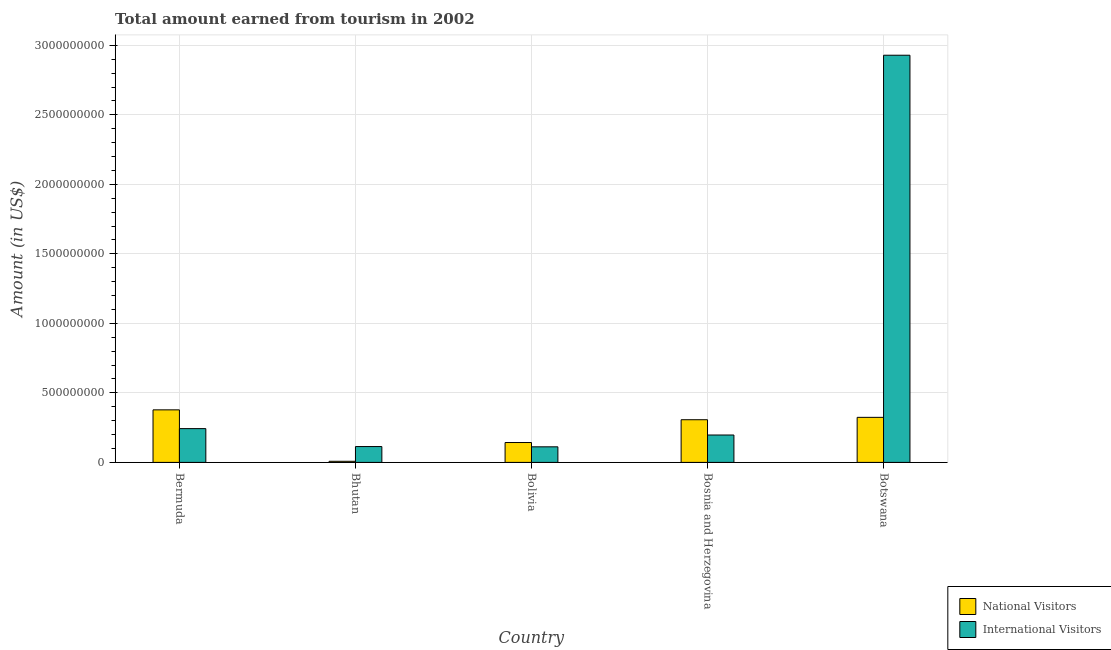How many different coloured bars are there?
Your answer should be very brief. 2. How many groups of bars are there?
Ensure brevity in your answer.  5. Are the number of bars on each tick of the X-axis equal?
Make the answer very short. Yes. How many bars are there on the 1st tick from the left?
Ensure brevity in your answer.  2. What is the label of the 2nd group of bars from the left?
Make the answer very short. Bhutan. In how many cases, is the number of bars for a given country not equal to the number of legend labels?
Make the answer very short. 0. Across all countries, what is the maximum amount earned from national visitors?
Make the answer very short. 3.78e+08. In which country was the amount earned from international visitors maximum?
Your answer should be compact. Botswana. In which country was the amount earned from international visitors minimum?
Make the answer very short. Bolivia. What is the total amount earned from international visitors in the graph?
Your response must be concise. 3.60e+09. What is the difference between the amount earned from international visitors in Bosnia and Herzegovina and that in Botswana?
Your response must be concise. -2.73e+09. What is the difference between the amount earned from national visitors in Bhutan and the amount earned from international visitors in Bosnia and Herzegovina?
Offer a very short reply. -1.89e+08. What is the average amount earned from international visitors per country?
Make the answer very short. 7.19e+08. What is the difference between the amount earned from international visitors and amount earned from national visitors in Bolivia?
Make the answer very short. -3.10e+07. In how many countries, is the amount earned from international visitors greater than 2600000000 US$?
Your answer should be very brief. 1. What is the ratio of the amount earned from international visitors in Bermuda to that in Bolivia?
Your answer should be compact. 2.17. Is the amount earned from national visitors in Bermuda less than that in Botswana?
Ensure brevity in your answer.  No. What is the difference between the highest and the second highest amount earned from national visitors?
Give a very brief answer. 5.40e+07. What is the difference between the highest and the lowest amount earned from international visitors?
Give a very brief answer. 2.82e+09. In how many countries, is the amount earned from national visitors greater than the average amount earned from national visitors taken over all countries?
Your response must be concise. 3. Is the sum of the amount earned from international visitors in Bolivia and Botswana greater than the maximum amount earned from national visitors across all countries?
Keep it short and to the point. Yes. What does the 2nd bar from the left in Bhutan represents?
Offer a terse response. International Visitors. What does the 2nd bar from the right in Bermuda represents?
Give a very brief answer. National Visitors. How many bars are there?
Offer a terse response. 10. How many countries are there in the graph?
Provide a short and direct response. 5. What is the difference between two consecutive major ticks on the Y-axis?
Keep it short and to the point. 5.00e+08. Where does the legend appear in the graph?
Make the answer very short. Bottom right. How many legend labels are there?
Ensure brevity in your answer.  2. What is the title of the graph?
Your response must be concise. Total amount earned from tourism in 2002. Does "All education staff compensation" appear as one of the legend labels in the graph?
Make the answer very short. No. What is the Amount (in US$) in National Visitors in Bermuda?
Offer a terse response. 3.78e+08. What is the Amount (in US$) of International Visitors in Bermuda?
Keep it short and to the point. 2.43e+08. What is the Amount (in US$) of International Visitors in Bhutan?
Ensure brevity in your answer.  1.14e+08. What is the Amount (in US$) in National Visitors in Bolivia?
Make the answer very short. 1.43e+08. What is the Amount (in US$) of International Visitors in Bolivia?
Keep it short and to the point. 1.12e+08. What is the Amount (in US$) in National Visitors in Bosnia and Herzegovina?
Your answer should be compact. 3.07e+08. What is the Amount (in US$) in International Visitors in Bosnia and Herzegovina?
Ensure brevity in your answer.  1.97e+08. What is the Amount (in US$) of National Visitors in Botswana?
Give a very brief answer. 3.24e+08. What is the Amount (in US$) of International Visitors in Botswana?
Provide a short and direct response. 2.93e+09. Across all countries, what is the maximum Amount (in US$) in National Visitors?
Give a very brief answer. 3.78e+08. Across all countries, what is the maximum Amount (in US$) of International Visitors?
Provide a succinct answer. 2.93e+09. Across all countries, what is the minimum Amount (in US$) in International Visitors?
Ensure brevity in your answer.  1.12e+08. What is the total Amount (in US$) of National Visitors in the graph?
Ensure brevity in your answer.  1.16e+09. What is the total Amount (in US$) of International Visitors in the graph?
Your answer should be very brief. 3.60e+09. What is the difference between the Amount (in US$) in National Visitors in Bermuda and that in Bhutan?
Your answer should be compact. 3.70e+08. What is the difference between the Amount (in US$) of International Visitors in Bermuda and that in Bhutan?
Provide a succinct answer. 1.29e+08. What is the difference between the Amount (in US$) of National Visitors in Bermuda and that in Bolivia?
Your answer should be very brief. 2.35e+08. What is the difference between the Amount (in US$) in International Visitors in Bermuda and that in Bolivia?
Ensure brevity in your answer.  1.31e+08. What is the difference between the Amount (in US$) of National Visitors in Bermuda and that in Bosnia and Herzegovina?
Make the answer very short. 7.10e+07. What is the difference between the Amount (in US$) of International Visitors in Bermuda and that in Bosnia and Herzegovina?
Your answer should be compact. 4.60e+07. What is the difference between the Amount (in US$) in National Visitors in Bermuda and that in Botswana?
Offer a very short reply. 5.40e+07. What is the difference between the Amount (in US$) in International Visitors in Bermuda and that in Botswana?
Provide a short and direct response. -2.69e+09. What is the difference between the Amount (in US$) in National Visitors in Bhutan and that in Bolivia?
Your response must be concise. -1.35e+08. What is the difference between the Amount (in US$) of International Visitors in Bhutan and that in Bolivia?
Ensure brevity in your answer.  2.00e+06. What is the difference between the Amount (in US$) in National Visitors in Bhutan and that in Bosnia and Herzegovina?
Provide a succinct answer. -2.99e+08. What is the difference between the Amount (in US$) in International Visitors in Bhutan and that in Bosnia and Herzegovina?
Provide a short and direct response. -8.30e+07. What is the difference between the Amount (in US$) of National Visitors in Bhutan and that in Botswana?
Offer a very short reply. -3.16e+08. What is the difference between the Amount (in US$) in International Visitors in Bhutan and that in Botswana?
Your response must be concise. -2.82e+09. What is the difference between the Amount (in US$) in National Visitors in Bolivia and that in Bosnia and Herzegovina?
Provide a succinct answer. -1.64e+08. What is the difference between the Amount (in US$) in International Visitors in Bolivia and that in Bosnia and Herzegovina?
Offer a very short reply. -8.50e+07. What is the difference between the Amount (in US$) in National Visitors in Bolivia and that in Botswana?
Give a very brief answer. -1.81e+08. What is the difference between the Amount (in US$) of International Visitors in Bolivia and that in Botswana?
Ensure brevity in your answer.  -2.82e+09. What is the difference between the Amount (in US$) of National Visitors in Bosnia and Herzegovina and that in Botswana?
Your answer should be very brief. -1.70e+07. What is the difference between the Amount (in US$) in International Visitors in Bosnia and Herzegovina and that in Botswana?
Make the answer very short. -2.73e+09. What is the difference between the Amount (in US$) in National Visitors in Bermuda and the Amount (in US$) in International Visitors in Bhutan?
Offer a terse response. 2.64e+08. What is the difference between the Amount (in US$) in National Visitors in Bermuda and the Amount (in US$) in International Visitors in Bolivia?
Offer a terse response. 2.66e+08. What is the difference between the Amount (in US$) of National Visitors in Bermuda and the Amount (in US$) of International Visitors in Bosnia and Herzegovina?
Provide a succinct answer. 1.81e+08. What is the difference between the Amount (in US$) in National Visitors in Bermuda and the Amount (in US$) in International Visitors in Botswana?
Provide a succinct answer. -2.55e+09. What is the difference between the Amount (in US$) in National Visitors in Bhutan and the Amount (in US$) in International Visitors in Bolivia?
Give a very brief answer. -1.04e+08. What is the difference between the Amount (in US$) of National Visitors in Bhutan and the Amount (in US$) of International Visitors in Bosnia and Herzegovina?
Ensure brevity in your answer.  -1.89e+08. What is the difference between the Amount (in US$) in National Visitors in Bhutan and the Amount (in US$) in International Visitors in Botswana?
Make the answer very short. -2.92e+09. What is the difference between the Amount (in US$) in National Visitors in Bolivia and the Amount (in US$) in International Visitors in Bosnia and Herzegovina?
Provide a succinct answer. -5.40e+07. What is the difference between the Amount (in US$) of National Visitors in Bolivia and the Amount (in US$) of International Visitors in Botswana?
Provide a short and direct response. -2.79e+09. What is the difference between the Amount (in US$) in National Visitors in Bosnia and Herzegovina and the Amount (in US$) in International Visitors in Botswana?
Make the answer very short. -2.62e+09. What is the average Amount (in US$) in National Visitors per country?
Make the answer very short. 2.32e+08. What is the average Amount (in US$) in International Visitors per country?
Provide a succinct answer. 7.19e+08. What is the difference between the Amount (in US$) in National Visitors and Amount (in US$) in International Visitors in Bermuda?
Your response must be concise. 1.35e+08. What is the difference between the Amount (in US$) in National Visitors and Amount (in US$) in International Visitors in Bhutan?
Offer a terse response. -1.06e+08. What is the difference between the Amount (in US$) of National Visitors and Amount (in US$) of International Visitors in Bolivia?
Your response must be concise. 3.10e+07. What is the difference between the Amount (in US$) of National Visitors and Amount (in US$) of International Visitors in Bosnia and Herzegovina?
Offer a very short reply. 1.10e+08. What is the difference between the Amount (in US$) in National Visitors and Amount (in US$) in International Visitors in Botswana?
Your response must be concise. -2.60e+09. What is the ratio of the Amount (in US$) in National Visitors in Bermuda to that in Bhutan?
Provide a short and direct response. 47.25. What is the ratio of the Amount (in US$) of International Visitors in Bermuda to that in Bhutan?
Your response must be concise. 2.13. What is the ratio of the Amount (in US$) in National Visitors in Bermuda to that in Bolivia?
Ensure brevity in your answer.  2.64. What is the ratio of the Amount (in US$) of International Visitors in Bermuda to that in Bolivia?
Keep it short and to the point. 2.17. What is the ratio of the Amount (in US$) of National Visitors in Bermuda to that in Bosnia and Herzegovina?
Give a very brief answer. 1.23. What is the ratio of the Amount (in US$) in International Visitors in Bermuda to that in Bosnia and Herzegovina?
Provide a succinct answer. 1.23. What is the ratio of the Amount (in US$) in National Visitors in Bermuda to that in Botswana?
Ensure brevity in your answer.  1.17. What is the ratio of the Amount (in US$) in International Visitors in Bermuda to that in Botswana?
Your answer should be very brief. 0.08. What is the ratio of the Amount (in US$) of National Visitors in Bhutan to that in Bolivia?
Keep it short and to the point. 0.06. What is the ratio of the Amount (in US$) in International Visitors in Bhutan to that in Bolivia?
Make the answer very short. 1.02. What is the ratio of the Amount (in US$) in National Visitors in Bhutan to that in Bosnia and Herzegovina?
Your answer should be very brief. 0.03. What is the ratio of the Amount (in US$) of International Visitors in Bhutan to that in Bosnia and Herzegovina?
Keep it short and to the point. 0.58. What is the ratio of the Amount (in US$) in National Visitors in Bhutan to that in Botswana?
Your response must be concise. 0.02. What is the ratio of the Amount (in US$) in International Visitors in Bhutan to that in Botswana?
Provide a short and direct response. 0.04. What is the ratio of the Amount (in US$) of National Visitors in Bolivia to that in Bosnia and Herzegovina?
Provide a succinct answer. 0.47. What is the ratio of the Amount (in US$) in International Visitors in Bolivia to that in Bosnia and Herzegovina?
Your answer should be compact. 0.57. What is the ratio of the Amount (in US$) of National Visitors in Bolivia to that in Botswana?
Give a very brief answer. 0.44. What is the ratio of the Amount (in US$) of International Visitors in Bolivia to that in Botswana?
Keep it short and to the point. 0.04. What is the ratio of the Amount (in US$) of National Visitors in Bosnia and Herzegovina to that in Botswana?
Offer a very short reply. 0.95. What is the ratio of the Amount (in US$) of International Visitors in Bosnia and Herzegovina to that in Botswana?
Provide a short and direct response. 0.07. What is the difference between the highest and the second highest Amount (in US$) of National Visitors?
Offer a very short reply. 5.40e+07. What is the difference between the highest and the second highest Amount (in US$) in International Visitors?
Ensure brevity in your answer.  2.69e+09. What is the difference between the highest and the lowest Amount (in US$) of National Visitors?
Keep it short and to the point. 3.70e+08. What is the difference between the highest and the lowest Amount (in US$) of International Visitors?
Your answer should be compact. 2.82e+09. 